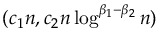Convert formula to latex. <formula><loc_0><loc_0><loc_500><loc_500>( c _ { 1 } n , c _ { 2 } n \log ^ { \beta _ { 1 } - \beta _ { 2 } } n )</formula> 